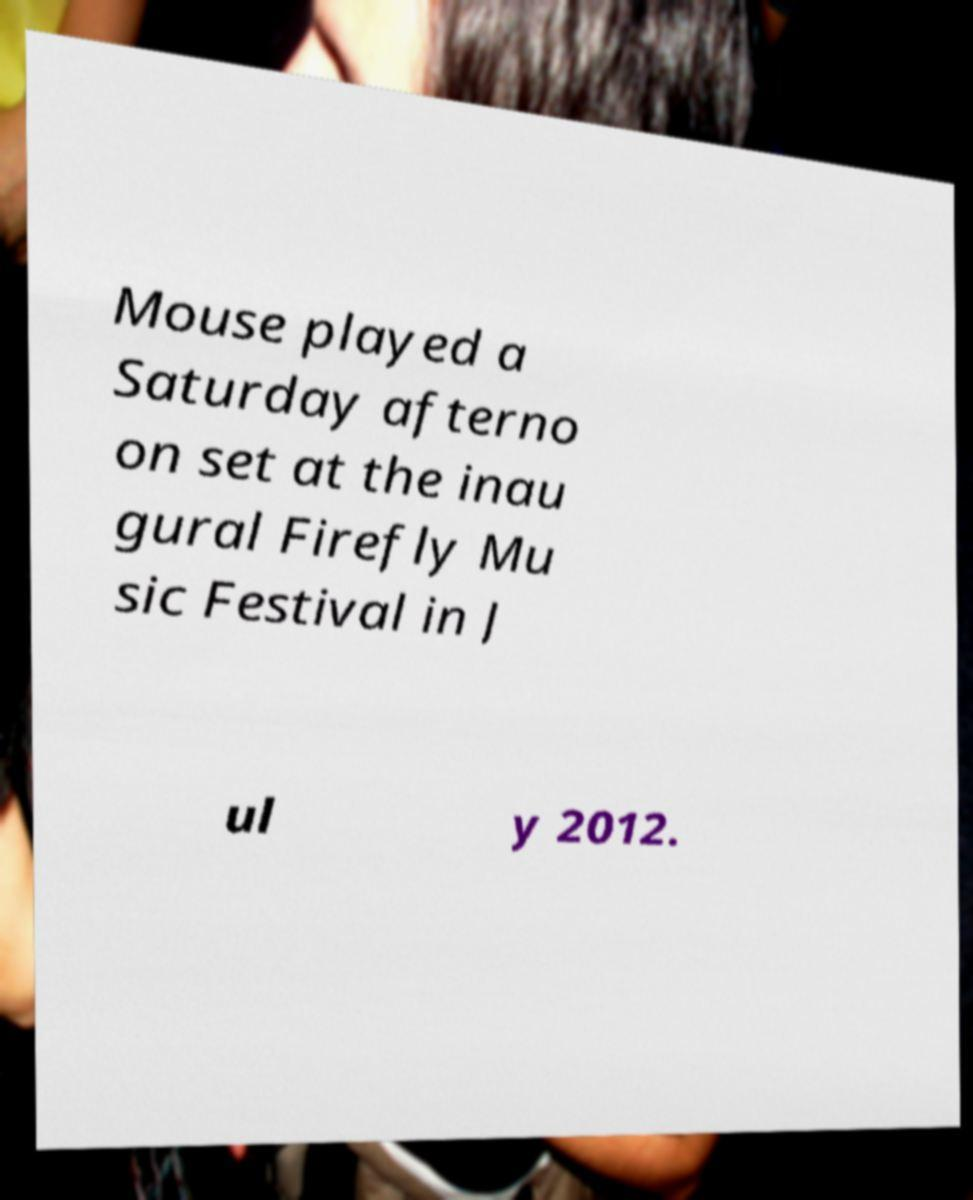Could you assist in decoding the text presented in this image and type it out clearly? Mouse played a Saturday afterno on set at the inau gural Firefly Mu sic Festival in J ul y 2012. 